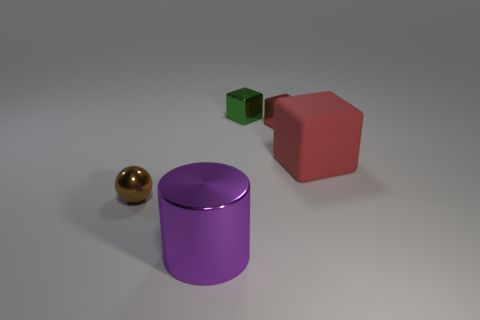Are there any other things that have the same material as the large red cube?
Your answer should be very brief. No. There is a small brown thing; are there any large red matte cubes in front of it?
Offer a very short reply. No. Are there more things that are in front of the green metallic block than brown things that are in front of the purple shiny thing?
Provide a short and direct response. Yes. There is a red metal thing that is the same shape as the tiny green shiny thing; what is its size?
Your response must be concise. Small. What number of balls are large brown objects or tiny red things?
Your response must be concise. 0. There is a small cube that is the same color as the matte thing; what is it made of?
Keep it short and to the point. Metal. Are there fewer rubber cubes that are behind the small red shiny thing than spheres in front of the purple object?
Your answer should be very brief. No. How many things are big things that are behind the purple metal thing or rubber blocks?
Offer a terse response. 1. What is the shape of the small shiny object that is in front of the tiny shiny thing to the right of the tiny green cube?
Your answer should be very brief. Sphere. Are there any red metal objects of the same size as the sphere?
Your answer should be very brief. Yes. 